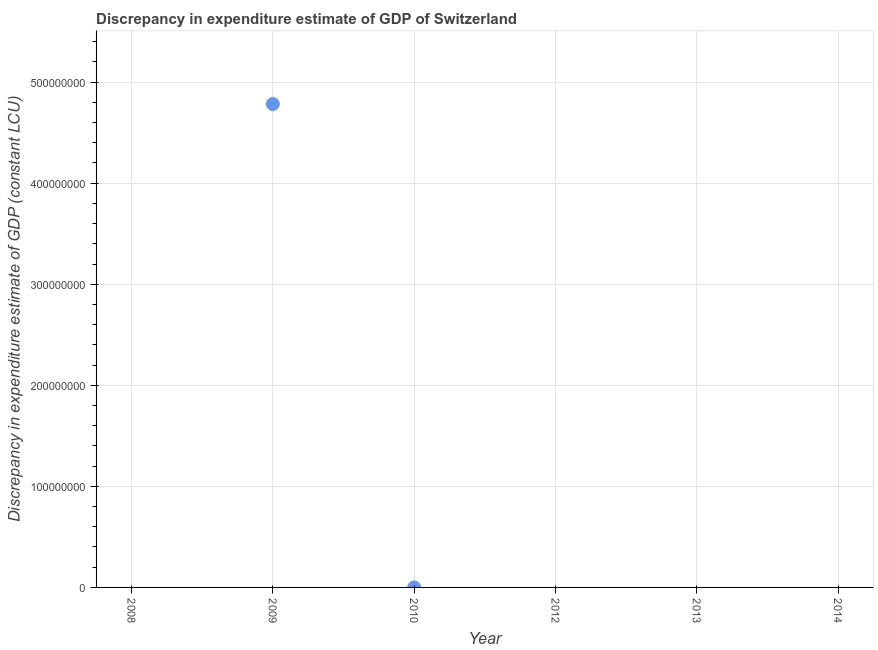What is the discrepancy in expenditure estimate of gdp in 2010?
Your answer should be compact. 100. Across all years, what is the maximum discrepancy in expenditure estimate of gdp?
Offer a terse response. 4.78e+08. In which year was the discrepancy in expenditure estimate of gdp maximum?
Keep it short and to the point. 2009. What is the sum of the discrepancy in expenditure estimate of gdp?
Provide a short and direct response. 4.78e+08. What is the average discrepancy in expenditure estimate of gdp per year?
Provide a succinct answer. 7.97e+07. What is the median discrepancy in expenditure estimate of gdp?
Make the answer very short. 0. In how many years, is the discrepancy in expenditure estimate of gdp greater than 100000000 LCU?
Give a very brief answer. 1. What is the ratio of the discrepancy in expenditure estimate of gdp in 2009 to that in 2010?
Offer a very short reply. 4.78e+06. Is the discrepancy in expenditure estimate of gdp in 2009 less than that in 2010?
Give a very brief answer. No. Is the sum of the discrepancy in expenditure estimate of gdp in 2009 and 2010 greater than the maximum discrepancy in expenditure estimate of gdp across all years?
Your answer should be very brief. Yes. What is the difference between the highest and the lowest discrepancy in expenditure estimate of gdp?
Keep it short and to the point. 4.78e+08. Does the discrepancy in expenditure estimate of gdp monotonically increase over the years?
Offer a very short reply. No. How many dotlines are there?
Provide a short and direct response. 1. Are the values on the major ticks of Y-axis written in scientific E-notation?
Keep it short and to the point. No. Does the graph contain grids?
Keep it short and to the point. Yes. What is the title of the graph?
Your answer should be compact. Discrepancy in expenditure estimate of GDP of Switzerland. What is the label or title of the X-axis?
Provide a short and direct response. Year. What is the label or title of the Y-axis?
Provide a short and direct response. Discrepancy in expenditure estimate of GDP (constant LCU). What is the Discrepancy in expenditure estimate of GDP (constant LCU) in 2008?
Make the answer very short. 0. What is the Discrepancy in expenditure estimate of GDP (constant LCU) in 2009?
Offer a very short reply. 4.78e+08. What is the Discrepancy in expenditure estimate of GDP (constant LCU) in 2010?
Your answer should be compact. 100. What is the Discrepancy in expenditure estimate of GDP (constant LCU) in 2013?
Your answer should be compact. 0. What is the difference between the Discrepancy in expenditure estimate of GDP (constant LCU) in 2009 and 2010?
Keep it short and to the point. 4.78e+08. What is the ratio of the Discrepancy in expenditure estimate of GDP (constant LCU) in 2009 to that in 2010?
Offer a very short reply. 4.78e+06. 